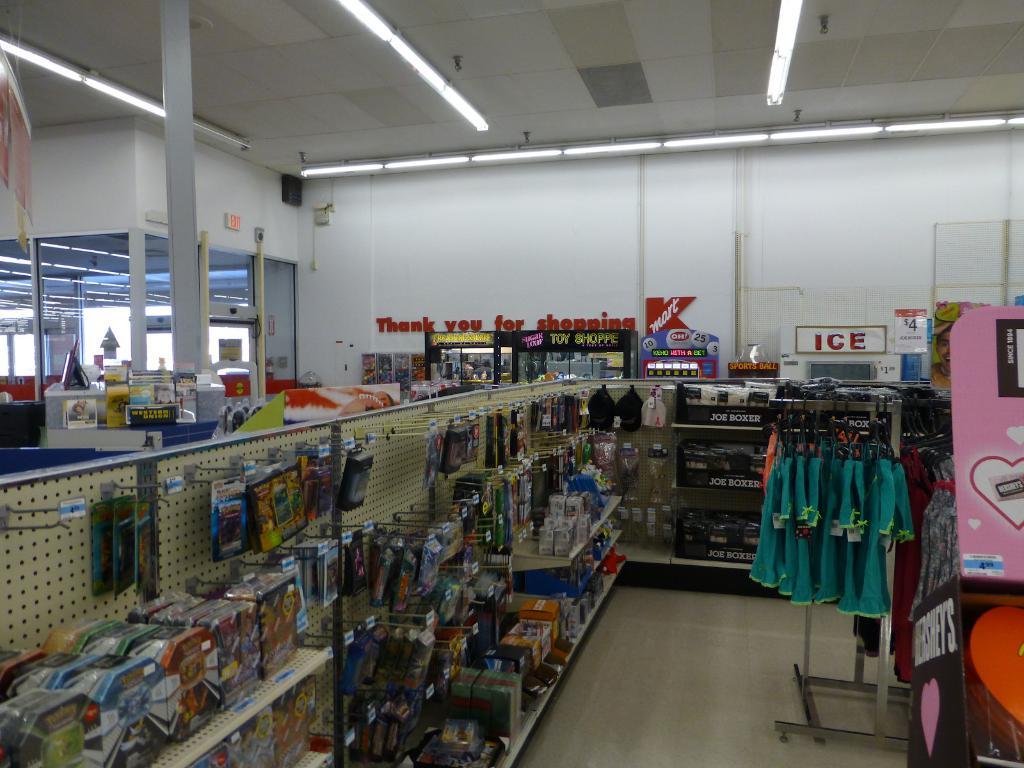Is there an ice machine in this store?
Provide a short and direct response. Yes. What does the red letters on the white wall in the back say?
Provide a short and direct response. Thank you for shopping. 